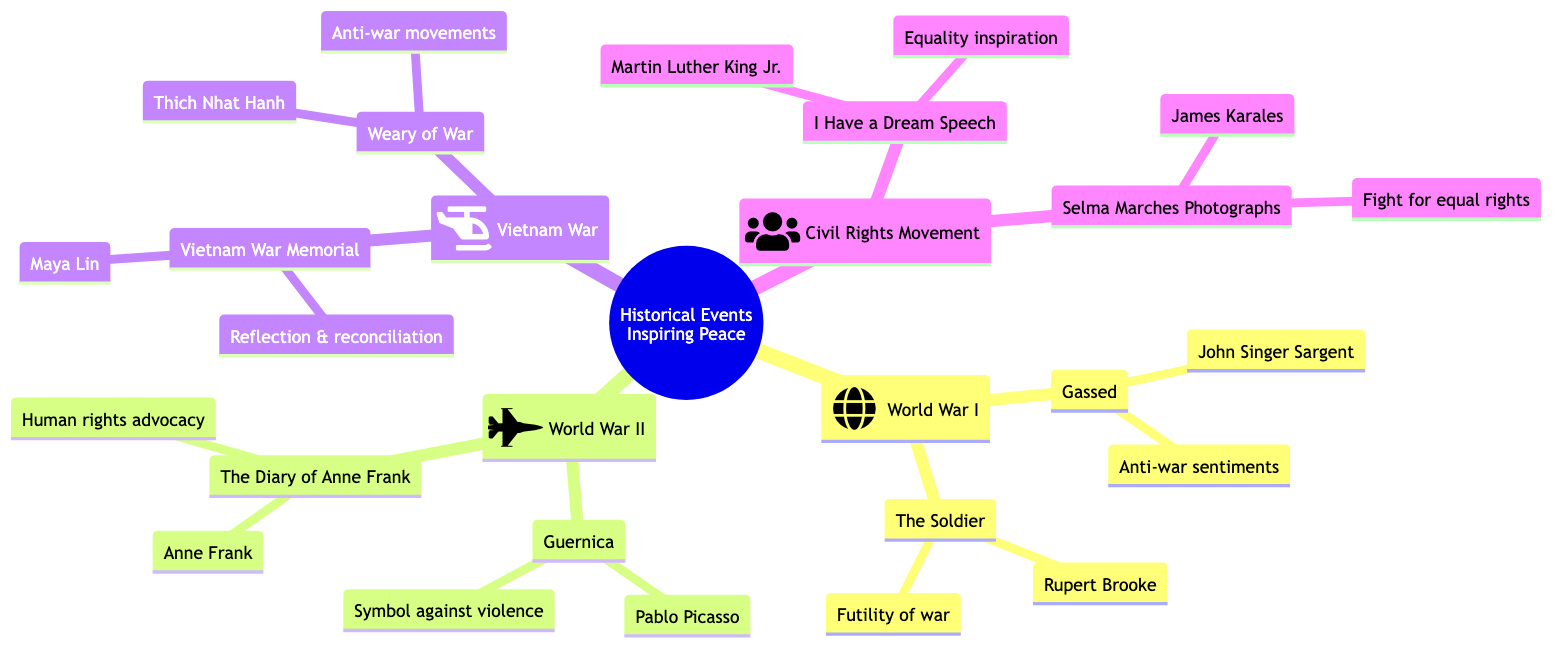What historical event is associated with the artwork "Gassed"? The diagram indicates that "Gassed" is related to World War I, which is listed as one of the historical events.
Answer: World War I Who is the artist of "Guernica"? The diagram provides the title "Guernica" under World War II, with the accompanying artist's name listed as Pablo Picasso.
Answer: Pablo Picasso How many artworks resulted from the Civil Rights Movement? The diagram shows two artworks listed under the Civil Rights Movement, specifically "I Have a Dream Speech" and "Selma Marches Photographs."
Answer: Two What is the impact of "The Diary of Anne Frank" on society? By examining the section under World War II, it states that "The Diary of Anne Frank" fosters empathy and understanding, advocating for human rights and peace.
Answer: Human rights advocacy Which artwork represents the Vietnam War? Looking at the Vietnam War section, there are two artworks mentioned: "Vietnam War Memorial" and "Weary of War," indicating both represent this historical event.
Answer: Vietnam War Memorial What was a significant message conveyed by Martin Luther King Jr. in his work? The diagram highlights that "I Have a Dream Speech" is an inspirational piece for equality that had a defining impact on the civil rights movement.
Answer: Equality inspiration What type of memorial is the Vietnam War Memorial? In the diagram, it classifies the Vietnam War Memorial as a tribute that honors soldiers’ sacrifices while critiquing the war, leading to reflection and reconciliation.
Answer: Reflection & reconciliation Which historical event does "Weary of War" relate to? The diagram specifies that "Weary of War" is associated with the Vietnam War, detailing its context within that historical event listing.
Answer: Vietnam War What common theme is found in the artworks from both World Wars? Upon reviewing the artworks listed under World War I and World War II, a common theme of anti-war sentiments and the horrors of conflict is evident in the resulting artworks.
Answer: Anti-war sentiments 